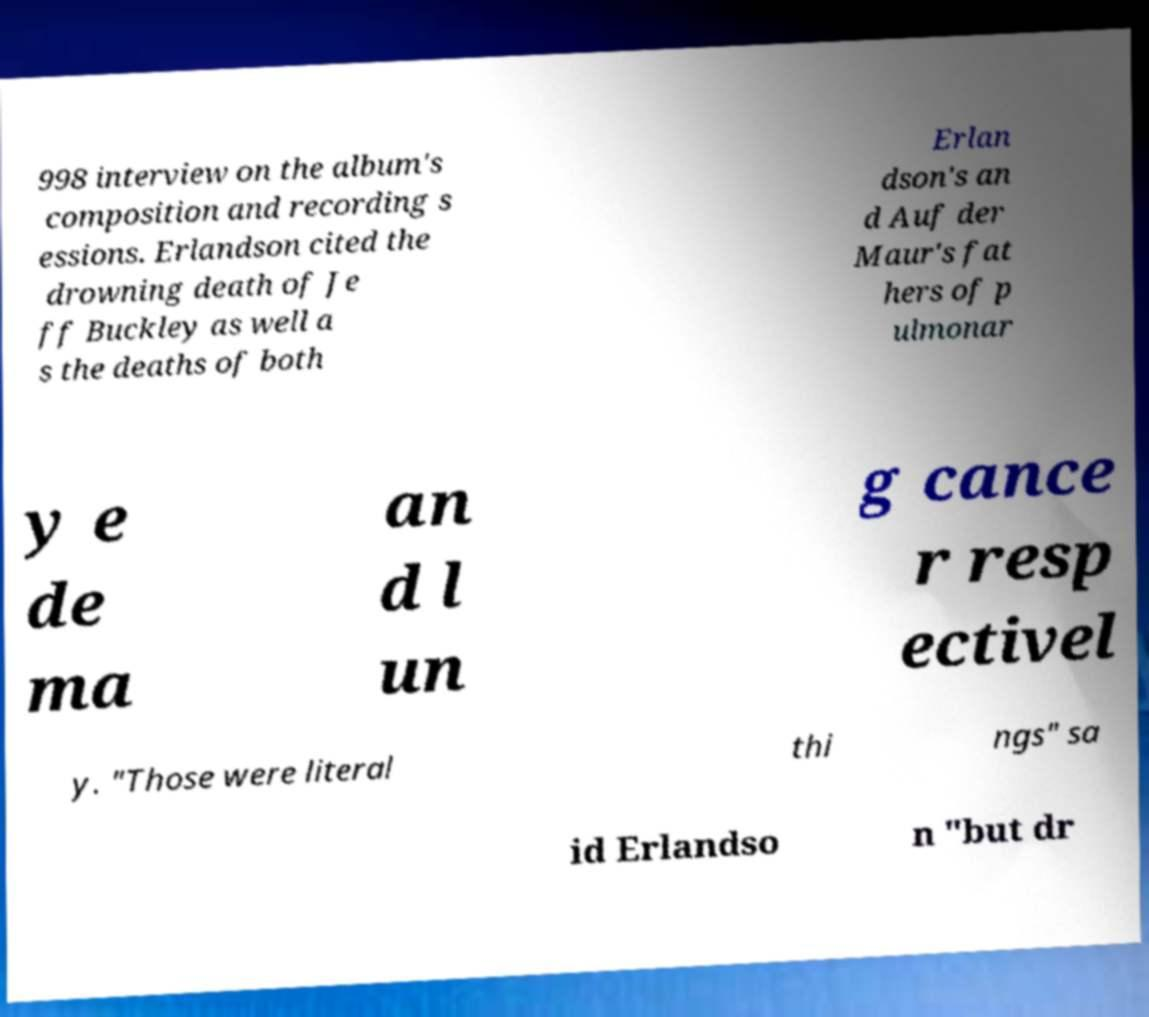Can you accurately transcribe the text from the provided image for me? 998 interview on the album's composition and recording s essions. Erlandson cited the drowning death of Je ff Buckley as well a s the deaths of both Erlan dson's an d Auf der Maur's fat hers of p ulmonar y e de ma an d l un g cance r resp ectivel y. "Those were literal thi ngs" sa id Erlandso n "but dr 